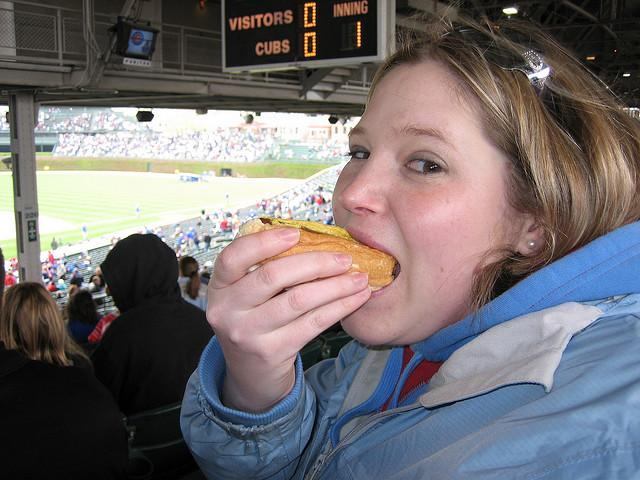The condiment on this food comes from where? Please explain your reasoning. mustard seed. It's obvious that mustard wouldn't come from anything else. 